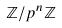<formula> <loc_0><loc_0><loc_500><loc_500>\mathbb { Z } / p ^ { n } \mathbb { Z }</formula> 